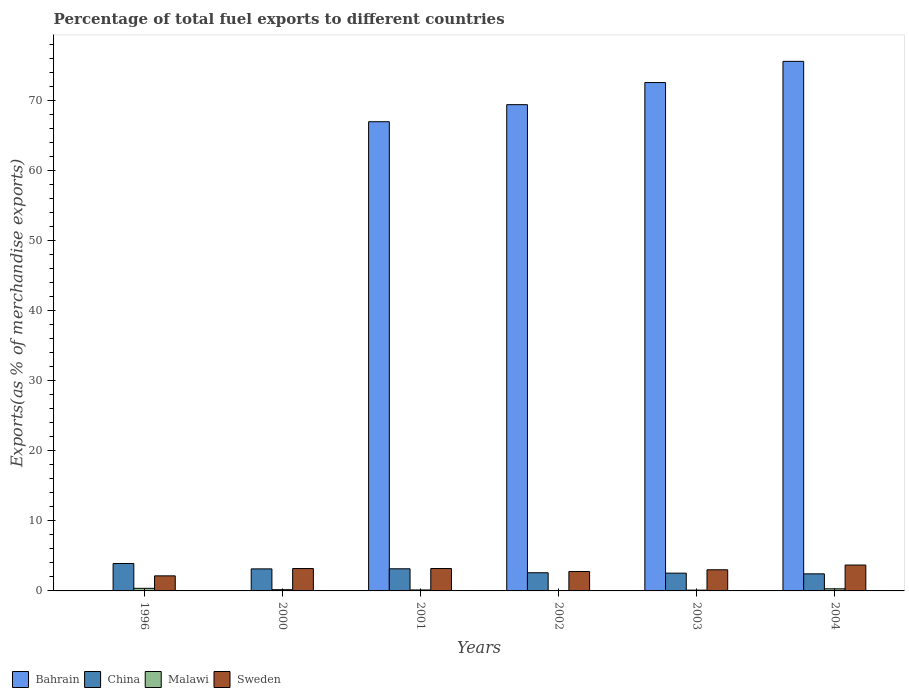How many groups of bars are there?
Provide a short and direct response. 6. How many bars are there on the 2nd tick from the left?
Offer a very short reply. 4. What is the percentage of exports to different countries in Sweden in 2000?
Ensure brevity in your answer.  3.19. Across all years, what is the maximum percentage of exports to different countries in Bahrain?
Ensure brevity in your answer.  75.54. Across all years, what is the minimum percentage of exports to different countries in Sweden?
Offer a terse response. 2.15. In which year was the percentage of exports to different countries in Malawi maximum?
Your response must be concise. 1996. What is the total percentage of exports to different countries in Bahrain in the graph?
Your response must be concise. 284.42. What is the difference between the percentage of exports to different countries in China in 1996 and that in 2004?
Give a very brief answer. 1.47. What is the difference between the percentage of exports to different countries in Sweden in 2000 and the percentage of exports to different countries in Bahrain in 1996?
Make the answer very short. 3.18. What is the average percentage of exports to different countries in Bahrain per year?
Provide a short and direct response. 47.4. In the year 2002, what is the difference between the percentage of exports to different countries in China and percentage of exports to different countries in Bahrain?
Give a very brief answer. -66.77. What is the ratio of the percentage of exports to different countries in China in 2001 to that in 2004?
Your response must be concise. 1.3. Is the difference between the percentage of exports to different countries in China in 2001 and 2002 greater than the difference between the percentage of exports to different countries in Bahrain in 2001 and 2002?
Give a very brief answer. Yes. What is the difference between the highest and the second highest percentage of exports to different countries in China?
Make the answer very short. 0.75. What is the difference between the highest and the lowest percentage of exports to different countries in Bahrain?
Offer a terse response. 75.53. What does the 2nd bar from the left in 2004 represents?
Make the answer very short. China. What does the 1st bar from the right in 2000 represents?
Give a very brief answer. Sweden. Is it the case that in every year, the sum of the percentage of exports to different countries in Malawi and percentage of exports to different countries in Sweden is greater than the percentage of exports to different countries in Bahrain?
Your answer should be very brief. No. How many bars are there?
Provide a short and direct response. 24. How many years are there in the graph?
Make the answer very short. 6. Are the values on the major ticks of Y-axis written in scientific E-notation?
Your answer should be very brief. No. How many legend labels are there?
Provide a succinct answer. 4. How are the legend labels stacked?
Keep it short and to the point. Horizontal. What is the title of the graph?
Keep it short and to the point. Percentage of total fuel exports to different countries. What is the label or title of the X-axis?
Ensure brevity in your answer.  Years. What is the label or title of the Y-axis?
Keep it short and to the point. Exports(as % of merchandise exports). What is the Exports(as % of merchandise exports) in Bahrain in 1996?
Your answer should be compact. 0.02. What is the Exports(as % of merchandise exports) of China in 1996?
Your response must be concise. 3.91. What is the Exports(as % of merchandise exports) of Malawi in 1996?
Make the answer very short. 0.37. What is the Exports(as % of merchandise exports) in Sweden in 1996?
Make the answer very short. 2.15. What is the Exports(as % of merchandise exports) of Bahrain in 2000?
Offer a terse response. 0.04. What is the Exports(as % of merchandise exports) of China in 2000?
Make the answer very short. 3.14. What is the Exports(as % of merchandise exports) in Malawi in 2000?
Keep it short and to the point. 0.18. What is the Exports(as % of merchandise exports) of Sweden in 2000?
Give a very brief answer. 3.19. What is the Exports(as % of merchandise exports) in Bahrain in 2001?
Offer a very short reply. 66.93. What is the Exports(as % of merchandise exports) of China in 2001?
Your response must be concise. 3.16. What is the Exports(as % of merchandise exports) in Malawi in 2001?
Ensure brevity in your answer.  0.14. What is the Exports(as % of merchandise exports) of Sweden in 2001?
Provide a succinct answer. 3.19. What is the Exports(as % of merchandise exports) in Bahrain in 2002?
Your answer should be very brief. 69.37. What is the Exports(as % of merchandise exports) in China in 2002?
Keep it short and to the point. 2.59. What is the Exports(as % of merchandise exports) in Malawi in 2002?
Offer a very short reply. 0.02. What is the Exports(as % of merchandise exports) of Sweden in 2002?
Make the answer very short. 2.77. What is the Exports(as % of merchandise exports) in Bahrain in 2003?
Provide a succinct answer. 72.52. What is the Exports(as % of merchandise exports) in China in 2003?
Your response must be concise. 2.54. What is the Exports(as % of merchandise exports) of Malawi in 2003?
Your response must be concise. 0.11. What is the Exports(as % of merchandise exports) in Sweden in 2003?
Make the answer very short. 3.02. What is the Exports(as % of merchandise exports) in Bahrain in 2004?
Offer a very short reply. 75.54. What is the Exports(as % of merchandise exports) in China in 2004?
Give a very brief answer. 2.43. What is the Exports(as % of merchandise exports) in Malawi in 2004?
Give a very brief answer. 0.3. What is the Exports(as % of merchandise exports) of Sweden in 2004?
Offer a very short reply. 3.69. Across all years, what is the maximum Exports(as % of merchandise exports) in Bahrain?
Your response must be concise. 75.54. Across all years, what is the maximum Exports(as % of merchandise exports) in China?
Your response must be concise. 3.91. Across all years, what is the maximum Exports(as % of merchandise exports) in Malawi?
Make the answer very short. 0.37. Across all years, what is the maximum Exports(as % of merchandise exports) in Sweden?
Ensure brevity in your answer.  3.69. Across all years, what is the minimum Exports(as % of merchandise exports) in Bahrain?
Your response must be concise. 0.02. Across all years, what is the minimum Exports(as % of merchandise exports) in China?
Ensure brevity in your answer.  2.43. Across all years, what is the minimum Exports(as % of merchandise exports) of Malawi?
Your answer should be very brief. 0.02. Across all years, what is the minimum Exports(as % of merchandise exports) of Sweden?
Provide a succinct answer. 2.15. What is the total Exports(as % of merchandise exports) of Bahrain in the graph?
Your answer should be very brief. 284.42. What is the total Exports(as % of merchandise exports) in China in the graph?
Provide a succinct answer. 17.77. What is the total Exports(as % of merchandise exports) of Malawi in the graph?
Ensure brevity in your answer.  1.11. What is the total Exports(as % of merchandise exports) in Sweden in the graph?
Your response must be concise. 18.02. What is the difference between the Exports(as % of merchandise exports) in Bahrain in 1996 and that in 2000?
Make the answer very short. -0.02. What is the difference between the Exports(as % of merchandise exports) of China in 1996 and that in 2000?
Provide a short and direct response. 0.76. What is the difference between the Exports(as % of merchandise exports) of Malawi in 1996 and that in 2000?
Your answer should be very brief. 0.2. What is the difference between the Exports(as % of merchandise exports) in Sweden in 1996 and that in 2000?
Keep it short and to the point. -1.04. What is the difference between the Exports(as % of merchandise exports) of Bahrain in 1996 and that in 2001?
Your response must be concise. -66.92. What is the difference between the Exports(as % of merchandise exports) of China in 1996 and that in 2001?
Ensure brevity in your answer.  0.75. What is the difference between the Exports(as % of merchandise exports) of Malawi in 1996 and that in 2001?
Make the answer very short. 0.24. What is the difference between the Exports(as % of merchandise exports) in Sweden in 1996 and that in 2001?
Your response must be concise. -1.05. What is the difference between the Exports(as % of merchandise exports) in Bahrain in 1996 and that in 2002?
Ensure brevity in your answer.  -69.35. What is the difference between the Exports(as % of merchandise exports) of China in 1996 and that in 2002?
Keep it short and to the point. 1.32. What is the difference between the Exports(as % of merchandise exports) in Malawi in 1996 and that in 2002?
Ensure brevity in your answer.  0.35. What is the difference between the Exports(as % of merchandise exports) of Sweden in 1996 and that in 2002?
Your response must be concise. -0.62. What is the difference between the Exports(as % of merchandise exports) of Bahrain in 1996 and that in 2003?
Your answer should be very brief. -72.5. What is the difference between the Exports(as % of merchandise exports) of China in 1996 and that in 2003?
Offer a terse response. 1.37. What is the difference between the Exports(as % of merchandise exports) of Malawi in 1996 and that in 2003?
Your answer should be very brief. 0.26. What is the difference between the Exports(as % of merchandise exports) of Sweden in 1996 and that in 2003?
Your answer should be very brief. -0.87. What is the difference between the Exports(as % of merchandise exports) of Bahrain in 1996 and that in 2004?
Your answer should be compact. -75.53. What is the difference between the Exports(as % of merchandise exports) in China in 1996 and that in 2004?
Provide a succinct answer. 1.47. What is the difference between the Exports(as % of merchandise exports) of Malawi in 1996 and that in 2004?
Your answer should be very brief. 0.07. What is the difference between the Exports(as % of merchandise exports) of Sweden in 1996 and that in 2004?
Offer a very short reply. -1.54. What is the difference between the Exports(as % of merchandise exports) of Bahrain in 2000 and that in 2001?
Your answer should be compact. -66.89. What is the difference between the Exports(as % of merchandise exports) in China in 2000 and that in 2001?
Give a very brief answer. -0.01. What is the difference between the Exports(as % of merchandise exports) in Malawi in 2000 and that in 2001?
Offer a very short reply. 0.04. What is the difference between the Exports(as % of merchandise exports) in Sweden in 2000 and that in 2001?
Your response must be concise. -0. What is the difference between the Exports(as % of merchandise exports) in Bahrain in 2000 and that in 2002?
Keep it short and to the point. -69.33. What is the difference between the Exports(as % of merchandise exports) of China in 2000 and that in 2002?
Your answer should be compact. 0.55. What is the difference between the Exports(as % of merchandise exports) of Malawi in 2000 and that in 2002?
Your answer should be very brief. 0.16. What is the difference between the Exports(as % of merchandise exports) in Sweden in 2000 and that in 2002?
Make the answer very short. 0.42. What is the difference between the Exports(as % of merchandise exports) of Bahrain in 2000 and that in 2003?
Offer a very short reply. -72.48. What is the difference between the Exports(as % of merchandise exports) of China in 2000 and that in 2003?
Offer a terse response. 0.61. What is the difference between the Exports(as % of merchandise exports) in Malawi in 2000 and that in 2003?
Your answer should be compact. 0.06. What is the difference between the Exports(as % of merchandise exports) of Sweden in 2000 and that in 2003?
Provide a short and direct response. 0.18. What is the difference between the Exports(as % of merchandise exports) in Bahrain in 2000 and that in 2004?
Your answer should be very brief. -75.5. What is the difference between the Exports(as % of merchandise exports) in China in 2000 and that in 2004?
Ensure brevity in your answer.  0.71. What is the difference between the Exports(as % of merchandise exports) in Malawi in 2000 and that in 2004?
Provide a short and direct response. -0.12. What is the difference between the Exports(as % of merchandise exports) in Sweden in 2000 and that in 2004?
Give a very brief answer. -0.5. What is the difference between the Exports(as % of merchandise exports) in Bahrain in 2001 and that in 2002?
Your answer should be very brief. -2.43. What is the difference between the Exports(as % of merchandise exports) of China in 2001 and that in 2002?
Keep it short and to the point. 0.57. What is the difference between the Exports(as % of merchandise exports) in Malawi in 2001 and that in 2002?
Your answer should be very brief. 0.12. What is the difference between the Exports(as % of merchandise exports) in Sweden in 2001 and that in 2002?
Make the answer very short. 0.42. What is the difference between the Exports(as % of merchandise exports) of Bahrain in 2001 and that in 2003?
Offer a terse response. -5.58. What is the difference between the Exports(as % of merchandise exports) in China in 2001 and that in 2003?
Provide a succinct answer. 0.62. What is the difference between the Exports(as % of merchandise exports) in Malawi in 2001 and that in 2003?
Ensure brevity in your answer.  0.02. What is the difference between the Exports(as % of merchandise exports) of Sweden in 2001 and that in 2003?
Offer a terse response. 0.18. What is the difference between the Exports(as % of merchandise exports) in Bahrain in 2001 and that in 2004?
Keep it short and to the point. -8.61. What is the difference between the Exports(as % of merchandise exports) of China in 2001 and that in 2004?
Your response must be concise. 0.72. What is the difference between the Exports(as % of merchandise exports) in Malawi in 2001 and that in 2004?
Your response must be concise. -0.16. What is the difference between the Exports(as % of merchandise exports) in Sweden in 2001 and that in 2004?
Offer a very short reply. -0.5. What is the difference between the Exports(as % of merchandise exports) in Bahrain in 2002 and that in 2003?
Offer a terse response. -3.15. What is the difference between the Exports(as % of merchandise exports) in China in 2002 and that in 2003?
Provide a succinct answer. 0.06. What is the difference between the Exports(as % of merchandise exports) of Malawi in 2002 and that in 2003?
Ensure brevity in your answer.  -0.09. What is the difference between the Exports(as % of merchandise exports) in Sweden in 2002 and that in 2003?
Offer a very short reply. -0.25. What is the difference between the Exports(as % of merchandise exports) in Bahrain in 2002 and that in 2004?
Make the answer very short. -6.18. What is the difference between the Exports(as % of merchandise exports) of China in 2002 and that in 2004?
Ensure brevity in your answer.  0.16. What is the difference between the Exports(as % of merchandise exports) of Malawi in 2002 and that in 2004?
Provide a succinct answer. -0.28. What is the difference between the Exports(as % of merchandise exports) in Sweden in 2002 and that in 2004?
Offer a terse response. -0.92. What is the difference between the Exports(as % of merchandise exports) of Bahrain in 2003 and that in 2004?
Provide a short and direct response. -3.03. What is the difference between the Exports(as % of merchandise exports) in China in 2003 and that in 2004?
Make the answer very short. 0.1. What is the difference between the Exports(as % of merchandise exports) in Malawi in 2003 and that in 2004?
Provide a short and direct response. -0.19. What is the difference between the Exports(as % of merchandise exports) of Sweden in 2003 and that in 2004?
Your answer should be very brief. -0.68. What is the difference between the Exports(as % of merchandise exports) in Bahrain in 1996 and the Exports(as % of merchandise exports) in China in 2000?
Ensure brevity in your answer.  -3.13. What is the difference between the Exports(as % of merchandise exports) of Bahrain in 1996 and the Exports(as % of merchandise exports) of Malawi in 2000?
Make the answer very short. -0.16. What is the difference between the Exports(as % of merchandise exports) in Bahrain in 1996 and the Exports(as % of merchandise exports) in Sweden in 2000?
Make the answer very short. -3.18. What is the difference between the Exports(as % of merchandise exports) of China in 1996 and the Exports(as % of merchandise exports) of Malawi in 2000?
Your response must be concise. 3.73. What is the difference between the Exports(as % of merchandise exports) in China in 1996 and the Exports(as % of merchandise exports) in Sweden in 2000?
Give a very brief answer. 0.71. What is the difference between the Exports(as % of merchandise exports) of Malawi in 1996 and the Exports(as % of merchandise exports) of Sweden in 2000?
Make the answer very short. -2.82. What is the difference between the Exports(as % of merchandise exports) in Bahrain in 1996 and the Exports(as % of merchandise exports) in China in 2001?
Provide a short and direct response. -3.14. What is the difference between the Exports(as % of merchandise exports) in Bahrain in 1996 and the Exports(as % of merchandise exports) in Malawi in 2001?
Your response must be concise. -0.12. What is the difference between the Exports(as % of merchandise exports) of Bahrain in 1996 and the Exports(as % of merchandise exports) of Sweden in 2001?
Provide a short and direct response. -3.18. What is the difference between the Exports(as % of merchandise exports) in China in 1996 and the Exports(as % of merchandise exports) in Malawi in 2001?
Offer a terse response. 3.77. What is the difference between the Exports(as % of merchandise exports) in China in 1996 and the Exports(as % of merchandise exports) in Sweden in 2001?
Your answer should be very brief. 0.71. What is the difference between the Exports(as % of merchandise exports) in Malawi in 1996 and the Exports(as % of merchandise exports) in Sweden in 2001?
Provide a succinct answer. -2.82. What is the difference between the Exports(as % of merchandise exports) of Bahrain in 1996 and the Exports(as % of merchandise exports) of China in 2002?
Make the answer very short. -2.57. What is the difference between the Exports(as % of merchandise exports) in Bahrain in 1996 and the Exports(as % of merchandise exports) in Malawi in 2002?
Your answer should be compact. -0. What is the difference between the Exports(as % of merchandise exports) of Bahrain in 1996 and the Exports(as % of merchandise exports) of Sweden in 2002?
Give a very brief answer. -2.75. What is the difference between the Exports(as % of merchandise exports) of China in 1996 and the Exports(as % of merchandise exports) of Malawi in 2002?
Your answer should be very brief. 3.89. What is the difference between the Exports(as % of merchandise exports) in China in 1996 and the Exports(as % of merchandise exports) in Sweden in 2002?
Your response must be concise. 1.14. What is the difference between the Exports(as % of merchandise exports) in Malawi in 1996 and the Exports(as % of merchandise exports) in Sweden in 2002?
Offer a terse response. -2.4. What is the difference between the Exports(as % of merchandise exports) of Bahrain in 1996 and the Exports(as % of merchandise exports) of China in 2003?
Your answer should be compact. -2.52. What is the difference between the Exports(as % of merchandise exports) of Bahrain in 1996 and the Exports(as % of merchandise exports) of Malawi in 2003?
Keep it short and to the point. -0.09. What is the difference between the Exports(as % of merchandise exports) of Bahrain in 1996 and the Exports(as % of merchandise exports) of Sweden in 2003?
Your response must be concise. -3. What is the difference between the Exports(as % of merchandise exports) of China in 1996 and the Exports(as % of merchandise exports) of Malawi in 2003?
Keep it short and to the point. 3.8. What is the difference between the Exports(as % of merchandise exports) of China in 1996 and the Exports(as % of merchandise exports) of Sweden in 2003?
Make the answer very short. 0.89. What is the difference between the Exports(as % of merchandise exports) in Malawi in 1996 and the Exports(as % of merchandise exports) in Sweden in 2003?
Offer a terse response. -2.64. What is the difference between the Exports(as % of merchandise exports) in Bahrain in 1996 and the Exports(as % of merchandise exports) in China in 2004?
Give a very brief answer. -2.42. What is the difference between the Exports(as % of merchandise exports) in Bahrain in 1996 and the Exports(as % of merchandise exports) in Malawi in 2004?
Keep it short and to the point. -0.28. What is the difference between the Exports(as % of merchandise exports) of Bahrain in 1996 and the Exports(as % of merchandise exports) of Sweden in 2004?
Ensure brevity in your answer.  -3.67. What is the difference between the Exports(as % of merchandise exports) of China in 1996 and the Exports(as % of merchandise exports) of Malawi in 2004?
Your answer should be compact. 3.61. What is the difference between the Exports(as % of merchandise exports) of China in 1996 and the Exports(as % of merchandise exports) of Sweden in 2004?
Your response must be concise. 0.22. What is the difference between the Exports(as % of merchandise exports) of Malawi in 1996 and the Exports(as % of merchandise exports) of Sweden in 2004?
Give a very brief answer. -3.32. What is the difference between the Exports(as % of merchandise exports) of Bahrain in 2000 and the Exports(as % of merchandise exports) of China in 2001?
Your answer should be compact. -3.12. What is the difference between the Exports(as % of merchandise exports) of Bahrain in 2000 and the Exports(as % of merchandise exports) of Malawi in 2001?
Provide a short and direct response. -0.1. What is the difference between the Exports(as % of merchandise exports) in Bahrain in 2000 and the Exports(as % of merchandise exports) in Sweden in 2001?
Your answer should be very brief. -3.15. What is the difference between the Exports(as % of merchandise exports) in China in 2000 and the Exports(as % of merchandise exports) in Malawi in 2001?
Offer a very short reply. 3.01. What is the difference between the Exports(as % of merchandise exports) in China in 2000 and the Exports(as % of merchandise exports) in Sweden in 2001?
Offer a terse response. -0.05. What is the difference between the Exports(as % of merchandise exports) in Malawi in 2000 and the Exports(as % of merchandise exports) in Sweden in 2001?
Keep it short and to the point. -3.02. What is the difference between the Exports(as % of merchandise exports) in Bahrain in 2000 and the Exports(as % of merchandise exports) in China in 2002?
Your answer should be compact. -2.55. What is the difference between the Exports(as % of merchandise exports) of Bahrain in 2000 and the Exports(as % of merchandise exports) of Malawi in 2002?
Your answer should be compact. 0.02. What is the difference between the Exports(as % of merchandise exports) in Bahrain in 2000 and the Exports(as % of merchandise exports) in Sweden in 2002?
Your response must be concise. -2.73. What is the difference between the Exports(as % of merchandise exports) in China in 2000 and the Exports(as % of merchandise exports) in Malawi in 2002?
Your response must be concise. 3.13. What is the difference between the Exports(as % of merchandise exports) of China in 2000 and the Exports(as % of merchandise exports) of Sweden in 2002?
Offer a terse response. 0.37. What is the difference between the Exports(as % of merchandise exports) of Malawi in 2000 and the Exports(as % of merchandise exports) of Sweden in 2002?
Provide a succinct answer. -2.6. What is the difference between the Exports(as % of merchandise exports) of Bahrain in 2000 and the Exports(as % of merchandise exports) of China in 2003?
Offer a very short reply. -2.5. What is the difference between the Exports(as % of merchandise exports) of Bahrain in 2000 and the Exports(as % of merchandise exports) of Malawi in 2003?
Give a very brief answer. -0.07. What is the difference between the Exports(as % of merchandise exports) of Bahrain in 2000 and the Exports(as % of merchandise exports) of Sweden in 2003?
Your answer should be compact. -2.98. What is the difference between the Exports(as % of merchandise exports) of China in 2000 and the Exports(as % of merchandise exports) of Malawi in 2003?
Make the answer very short. 3.03. What is the difference between the Exports(as % of merchandise exports) of China in 2000 and the Exports(as % of merchandise exports) of Sweden in 2003?
Your answer should be very brief. 0.13. What is the difference between the Exports(as % of merchandise exports) in Malawi in 2000 and the Exports(as % of merchandise exports) in Sweden in 2003?
Keep it short and to the point. -2.84. What is the difference between the Exports(as % of merchandise exports) of Bahrain in 2000 and the Exports(as % of merchandise exports) of China in 2004?
Provide a succinct answer. -2.39. What is the difference between the Exports(as % of merchandise exports) in Bahrain in 2000 and the Exports(as % of merchandise exports) in Malawi in 2004?
Your response must be concise. -0.26. What is the difference between the Exports(as % of merchandise exports) of Bahrain in 2000 and the Exports(as % of merchandise exports) of Sweden in 2004?
Offer a terse response. -3.65. What is the difference between the Exports(as % of merchandise exports) in China in 2000 and the Exports(as % of merchandise exports) in Malawi in 2004?
Your answer should be compact. 2.84. What is the difference between the Exports(as % of merchandise exports) of China in 2000 and the Exports(as % of merchandise exports) of Sweden in 2004?
Provide a succinct answer. -0.55. What is the difference between the Exports(as % of merchandise exports) in Malawi in 2000 and the Exports(as % of merchandise exports) in Sweden in 2004?
Your answer should be compact. -3.52. What is the difference between the Exports(as % of merchandise exports) in Bahrain in 2001 and the Exports(as % of merchandise exports) in China in 2002?
Provide a short and direct response. 64.34. What is the difference between the Exports(as % of merchandise exports) of Bahrain in 2001 and the Exports(as % of merchandise exports) of Malawi in 2002?
Your answer should be very brief. 66.92. What is the difference between the Exports(as % of merchandise exports) of Bahrain in 2001 and the Exports(as % of merchandise exports) of Sweden in 2002?
Give a very brief answer. 64.16. What is the difference between the Exports(as % of merchandise exports) in China in 2001 and the Exports(as % of merchandise exports) in Malawi in 2002?
Offer a terse response. 3.14. What is the difference between the Exports(as % of merchandise exports) of China in 2001 and the Exports(as % of merchandise exports) of Sweden in 2002?
Your response must be concise. 0.39. What is the difference between the Exports(as % of merchandise exports) in Malawi in 2001 and the Exports(as % of merchandise exports) in Sweden in 2002?
Your response must be concise. -2.63. What is the difference between the Exports(as % of merchandise exports) in Bahrain in 2001 and the Exports(as % of merchandise exports) in China in 2003?
Offer a terse response. 64.4. What is the difference between the Exports(as % of merchandise exports) of Bahrain in 2001 and the Exports(as % of merchandise exports) of Malawi in 2003?
Provide a short and direct response. 66.82. What is the difference between the Exports(as % of merchandise exports) of Bahrain in 2001 and the Exports(as % of merchandise exports) of Sweden in 2003?
Your response must be concise. 63.92. What is the difference between the Exports(as % of merchandise exports) in China in 2001 and the Exports(as % of merchandise exports) in Malawi in 2003?
Your response must be concise. 3.05. What is the difference between the Exports(as % of merchandise exports) in China in 2001 and the Exports(as % of merchandise exports) in Sweden in 2003?
Make the answer very short. 0.14. What is the difference between the Exports(as % of merchandise exports) in Malawi in 2001 and the Exports(as % of merchandise exports) in Sweden in 2003?
Offer a very short reply. -2.88. What is the difference between the Exports(as % of merchandise exports) of Bahrain in 2001 and the Exports(as % of merchandise exports) of China in 2004?
Keep it short and to the point. 64.5. What is the difference between the Exports(as % of merchandise exports) of Bahrain in 2001 and the Exports(as % of merchandise exports) of Malawi in 2004?
Keep it short and to the point. 66.63. What is the difference between the Exports(as % of merchandise exports) in Bahrain in 2001 and the Exports(as % of merchandise exports) in Sweden in 2004?
Your answer should be very brief. 63.24. What is the difference between the Exports(as % of merchandise exports) in China in 2001 and the Exports(as % of merchandise exports) in Malawi in 2004?
Provide a short and direct response. 2.86. What is the difference between the Exports(as % of merchandise exports) of China in 2001 and the Exports(as % of merchandise exports) of Sweden in 2004?
Provide a succinct answer. -0.54. What is the difference between the Exports(as % of merchandise exports) of Malawi in 2001 and the Exports(as % of merchandise exports) of Sweden in 2004?
Make the answer very short. -3.56. What is the difference between the Exports(as % of merchandise exports) of Bahrain in 2002 and the Exports(as % of merchandise exports) of China in 2003?
Offer a terse response. 66.83. What is the difference between the Exports(as % of merchandise exports) in Bahrain in 2002 and the Exports(as % of merchandise exports) in Malawi in 2003?
Keep it short and to the point. 69.25. What is the difference between the Exports(as % of merchandise exports) of Bahrain in 2002 and the Exports(as % of merchandise exports) of Sweden in 2003?
Keep it short and to the point. 66.35. What is the difference between the Exports(as % of merchandise exports) of China in 2002 and the Exports(as % of merchandise exports) of Malawi in 2003?
Provide a short and direct response. 2.48. What is the difference between the Exports(as % of merchandise exports) in China in 2002 and the Exports(as % of merchandise exports) in Sweden in 2003?
Offer a terse response. -0.42. What is the difference between the Exports(as % of merchandise exports) in Malawi in 2002 and the Exports(as % of merchandise exports) in Sweden in 2003?
Your answer should be very brief. -3. What is the difference between the Exports(as % of merchandise exports) in Bahrain in 2002 and the Exports(as % of merchandise exports) in China in 2004?
Ensure brevity in your answer.  66.93. What is the difference between the Exports(as % of merchandise exports) of Bahrain in 2002 and the Exports(as % of merchandise exports) of Malawi in 2004?
Give a very brief answer. 69.07. What is the difference between the Exports(as % of merchandise exports) of Bahrain in 2002 and the Exports(as % of merchandise exports) of Sweden in 2004?
Make the answer very short. 65.67. What is the difference between the Exports(as % of merchandise exports) in China in 2002 and the Exports(as % of merchandise exports) in Malawi in 2004?
Offer a terse response. 2.29. What is the difference between the Exports(as % of merchandise exports) in China in 2002 and the Exports(as % of merchandise exports) in Sweden in 2004?
Ensure brevity in your answer.  -1.1. What is the difference between the Exports(as % of merchandise exports) of Malawi in 2002 and the Exports(as % of merchandise exports) of Sweden in 2004?
Your answer should be very brief. -3.67. What is the difference between the Exports(as % of merchandise exports) in Bahrain in 2003 and the Exports(as % of merchandise exports) in China in 2004?
Keep it short and to the point. 70.08. What is the difference between the Exports(as % of merchandise exports) of Bahrain in 2003 and the Exports(as % of merchandise exports) of Malawi in 2004?
Make the answer very short. 72.22. What is the difference between the Exports(as % of merchandise exports) in Bahrain in 2003 and the Exports(as % of merchandise exports) in Sweden in 2004?
Your response must be concise. 68.83. What is the difference between the Exports(as % of merchandise exports) of China in 2003 and the Exports(as % of merchandise exports) of Malawi in 2004?
Keep it short and to the point. 2.24. What is the difference between the Exports(as % of merchandise exports) of China in 2003 and the Exports(as % of merchandise exports) of Sweden in 2004?
Give a very brief answer. -1.16. What is the difference between the Exports(as % of merchandise exports) in Malawi in 2003 and the Exports(as % of merchandise exports) in Sweden in 2004?
Offer a very short reply. -3.58. What is the average Exports(as % of merchandise exports) in Bahrain per year?
Your response must be concise. 47.4. What is the average Exports(as % of merchandise exports) of China per year?
Give a very brief answer. 2.96. What is the average Exports(as % of merchandise exports) of Malawi per year?
Provide a short and direct response. 0.19. What is the average Exports(as % of merchandise exports) of Sweden per year?
Your answer should be compact. 3. In the year 1996, what is the difference between the Exports(as % of merchandise exports) in Bahrain and Exports(as % of merchandise exports) in China?
Make the answer very short. -3.89. In the year 1996, what is the difference between the Exports(as % of merchandise exports) of Bahrain and Exports(as % of merchandise exports) of Malawi?
Give a very brief answer. -0.35. In the year 1996, what is the difference between the Exports(as % of merchandise exports) of Bahrain and Exports(as % of merchandise exports) of Sweden?
Offer a terse response. -2.13. In the year 1996, what is the difference between the Exports(as % of merchandise exports) in China and Exports(as % of merchandise exports) in Malawi?
Make the answer very short. 3.54. In the year 1996, what is the difference between the Exports(as % of merchandise exports) of China and Exports(as % of merchandise exports) of Sweden?
Provide a succinct answer. 1.76. In the year 1996, what is the difference between the Exports(as % of merchandise exports) in Malawi and Exports(as % of merchandise exports) in Sweden?
Keep it short and to the point. -1.78. In the year 2000, what is the difference between the Exports(as % of merchandise exports) of Bahrain and Exports(as % of merchandise exports) of China?
Provide a short and direct response. -3.1. In the year 2000, what is the difference between the Exports(as % of merchandise exports) in Bahrain and Exports(as % of merchandise exports) in Malawi?
Provide a succinct answer. -0.14. In the year 2000, what is the difference between the Exports(as % of merchandise exports) in Bahrain and Exports(as % of merchandise exports) in Sweden?
Make the answer very short. -3.15. In the year 2000, what is the difference between the Exports(as % of merchandise exports) of China and Exports(as % of merchandise exports) of Malawi?
Make the answer very short. 2.97. In the year 2000, what is the difference between the Exports(as % of merchandise exports) in China and Exports(as % of merchandise exports) in Sweden?
Your answer should be very brief. -0.05. In the year 2000, what is the difference between the Exports(as % of merchandise exports) in Malawi and Exports(as % of merchandise exports) in Sweden?
Offer a very short reply. -3.02. In the year 2001, what is the difference between the Exports(as % of merchandise exports) of Bahrain and Exports(as % of merchandise exports) of China?
Provide a succinct answer. 63.78. In the year 2001, what is the difference between the Exports(as % of merchandise exports) in Bahrain and Exports(as % of merchandise exports) in Malawi?
Your answer should be compact. 66.8. In the year 2001, what is the difference between the Exports(as % of merchandise exports) in Bahrain and Exports(as % of merchandise exports) in Sweden?
Your answer should be compact. 63.74. In the year 2001, what is the difference between the Exports(as % of merchandise exports) of China and Exports(as % of merchandise exports) of Malawi?
Your answer should be very brief. 3.02. In the year 2001, what is the difference between the Exports(as % of merchandise exports) in China and Exports(as % of merchandise exports) in Sweden?
Your response must be concise. -0.04. In the year 2001, what is the difference between the Exports(as % of merchandise exports) of Malawi and Exports(as % of merchandise exports) of Sweden?
Provide a succinct answer. -3.06. In the year 2002, what is the difference between the Exports(as % of merchandise exports) of Bahrain and Exports(as % of merchandise exports) of China?
Your answer should be compact. 66.77. In the year 2002, what is the difference between the Exports(as % of merchandise exports) of Bahrain and Exports(as % of merchandise exports) of Malawi?
Your answer should be very brief. 69.35. In the year 2002, what is the difference between the Exports(as % of merchandise exports) in Bahrain and Exports(as % of merchandise exports) in Sweden?
Your answer should be compact. 66.6. In the year 2002, what is the difference between the Exports(as % of merchandise exports) of China and Exports(as % of merchandise exports) of Malawi?
Provide a short and direct response. 2.57. In the year 2002, what is the difference between the Exports(as % of merchandise exports) in China and Exports(as % of merchandise exports) in Sweden?
Provide a succinct answer. -0.18. In the year 2002, what is the difference between the Exports(as % of merchandise exports) in Malawi and Exports(as % of merchandise exports) in Sweden?
Your response must be concise. -2.75. In the year 2003, what is the difference between the Exports(as % of merchandise exports) of Bahrain and Exports(as % of merchandise exports) of China?
Your response must be concise. 69.98. In the year 2003, what is the difference between the Exports(as % of merchandise exports) of Bahrain and Exports(as % of merchandise exports) of Malawi?
Ensure brevity in your answer.  72.41. In the year 2003, what is the difference between the Exports(as % of merchandise exports) in Bahrain and Exports(as % of merchandise exports) in Sweden?
Ensure brevity in your answer.  69.5. In the year 2003, what is the difference between the Exports(as % of merchandise exports) of China and Exports(as % of merchandise exports) of Malawi?
Offer a very short reply. 2.42. In the year 2003, what is the difference between the Exports(as % of merchandise exports) of China and Exports(as % of merchandise exports) of Sweden?
Provide a short and direct response. -0.48. In the year 2003, what is the difference between the Exports(as % of merchandise exports) in Malawi and Exports(as % of merchandise exports) in Sweden?
Provide a short and direct response. -2.9. In the year 2004, what is the difference between the Exports(as % of merchandise exports) of Bahrain and Exports(as % of merchandise exports) of China?
Give a very brief answer. 73.11. In the year 2004, what is the difference between the Exports(as % of merchandise exports) of Bahrain and Exports(as % of merchandise exports) of Malawi?
Provide a short and direct response. 75.25. In the year 2004, what is the difference between the Exports(as % of merchandise exports) of Bahrain and Exports(as % of merchandise exports) of Sweden?
Make the answer very short. 71.85. In the year 2004, what is the difference between the Exports(as % of merchandise exports) in China and Exports(as % of merchandise exports) in Malawi?
Provide a short and direct response. 2.13. In the year 2004, what is the difference between the Exports(as % of merchandise exports) in China and Exports(as % of merchandise exports) in Sweden?
Give a very brief answer. -1.26. In the year 2004, what is the difference between the Exports(as % of merchandise exports) in Malawi and Exports(as % of merchandise exports) in Sweden?
Give a very brief answer. -3.39. What is the ratio of the Exports(as % of merchandise exports) in Bahrain in 1996 to that in 2000?
Your answer should be very brief. 0.44. What is the ratio of the Exports(as % of merchandise exports) of China in 1996 to that in 2000?
Your response must be concise. 1.24. What is the ratio of the Exports(as % of merchandise exports) in Malawi in 1996 to that in 2000?
Your answer should be very brief. 2.12. What is the ratio of the Exports(as % of merchandise exports) in Sweden in 1996 to that in 2000?
Your answer should be compact. 0.67. What is the ratio of the Exports(as % of merchandise exports) of Bahrain in 1996 to that in 2001?
Give a very brief answer. 0. What is the ratio of the Exports(as % of merchandise exports) in China in 1996 to that in 2001?
Your answer should be very brief. 1.24. What is the ratio of the Exports(as % of merchandise exports) in Malawi in 1996 to that in 2001?
Make the answer very short. 2.73. What is the ratio of the Exports(as % of merchandise exports) in Sweden in 1996 to that in 2001?
Your response must be concise. 0.67. What is the ratio of the Exports(as % of merchandise exports) in China in 1996 to that in 2002?
Provide a succinct answer. 1.51. What is the ratio of the Exports(as % of merchandise exports) of Malawi in 1996 to that in 2002?
Offer a terse response. 20.62. What is the ratio of the Exports(as % of merchandise exports) in Sweden in 1996 to that in 2002?
Offer a very short reply. 0.78. What is the ratio of the Exports(as % of merchandise exports) of China in 1996 to that in 2003?
Offer a terse response. 1.54. What is the ratio of the Exports(as % of merchandise exports) in Malawi in 1996 to that in 2003?
Provide a short and direct response. 3.32. What is the ratio of the Exports(as % of merchandise exports) of Sweden in 1996 to that in 2003?
Your answer should be very brief. 0.71. What is the ratio of the Exports(as % of merchandise exports) in Bahrain in 1996 to that in 2004?
Provide a short and direct response. 0. What is the ratio of the Exports(as % of merchandise exports) in China in 1996 to that in 2004?
Offer a very short reply. 1.61. What is the ratio of the Exports(as % of merchandise exports) of Malawi in 1996 to that in 2004?
Your answer should be very brief. 1.24. What is the ratio of the Exports(as % of merchandise exports) of Sweden in 1996 to that in 2004?
Make the answer very short. 0.58. What is the ratio of the Exports(as % of merchandise exports) in Bahrain in 2000 to that in 2001?
Make the answer very short. 0. What is the ratio of the Exports(as % of merchandise exports) in China in 2000 to that in 2001?
Make the answer very short. 1. What is the ratio of the Exports(as % of merchandise exports) in Malawi in 2000 to that in 2001?
Your answer should be very brief. 1.29. What is the ratio of the Exports(as % of merchandise exports) in Sweden in 2000 to that in 2001?
Provide a succinct answer. 1. What is the ratio of the Exports(as % of merchandise exports) of Bahrain in 2000 to that in 2002?
Keep it short and to the point. 0. What is the ratio of the Exports(as % of merchandise exports) in China in 2000 to that in 2002?
Keep it short and to the point. 1.21. What is the ratio of the Exports(as % of merchandise exports) of Malawi in 2000 to that in 2002?
Your answer should be very brief. 9.72. What is the ratio of the Exports(as % of merchandise exports) in Sweden in 2000 to that in 2002?
Provide a short and direct response. 1.15. What is the ratio of the Exports(as % of merchandise exports) of Bahrain in 2000 to that in 2003?
Your answer should be very brief. 0. What is the ratio of the Exports(as % of merchandise exports) of China in 2000 to that in 2003?
Offer a very short reply. 1.24. What is the ratio of the Exports(as % of merchandise exports) of Malawi in 2000 to that in 2003?
Keep it short and to the point. 1.56. What is the ratio of the Exports(as % of merchandise exports) of Sweden in 2000 to that in 2003?
Your answer should be very brief. 1.06. What is the ratio of the Exports(as % of merchandise exports) of China in 2000 to that in 2004?
Your response must be concise. 1.29. What is the ratio of the Exports(as % of merchandise exports) in Malawi in 2000 to that in 2004?
Provide a succinct answer. 0.59. What is the ratio of the Exports(as % of merchandise exports) of Sweden in 2000 to that in 2004?
Keep it short and to the point. 0.86. What is the ratio of the Exports(as % of merchandise exports) of Bahrain in 2001 to that in 2002?
Ensure brevity in your answer.  0.96. What is the ratio of the Exports(as % of merchandise exports) in China in 2001 to that in 2002?
Your response must be concise. 1.22. What is the ratio of the Exports(as % of merchandise exports) of Malawi in 2001 to that in 2002?
Ensure brevity in your answer.  7.55. What is the ratio of the Exports(as % of merchandise exports) in Sweden in 2001 to that in 2002?
Offer a very short reply. 1.15. What is the ratio of the Exports(as % of merchandise exports) of Bahrain in 2001 to that in 2003?
Offer a very short reply. 0.92. What is the ratio of the Exports(as % of merchandise exports) of China in 2001 to that in 2003?
Your response must be concise. 1.24. What is the ratio of the Exports(as % of merchandise exports) in Malawi in 2001 to that in 2003?
Keep it short and to the point. 1.21. What is the ratio of the Exports(as % of merchandise exports) in Sweden in 2001 to that in 2003?
Keep it short and to the point. 1.06. What is the ratio of the Exports(as % of merchandise exports) in Bahrain in 2001 to that in 2004?
Ensure brevity in your answer.  0.89. What is the ratio of the Exports(as % of merchandise exports) of China in 2001 to that in 2004?
Provide a short and direct response. 1.3. What is the ratio of the Exports(as % of merchandise exports) of Malawi in 2001 to that in 2004?
Your response must be concise. 0.45. What is the ratio of the Exports(as % of merchandise exports) in Sweden in 2001 to that in 2004?
Your response must be concise. 0.86. What is the ratio of the Exports(as % of merchandise exports) of Bahrain in 2002 to that in 2003?
Provide a short and direct response. 0.96. What is the ratio of the Exports(as % of merchandise exports) in Malawi in 2002 to that in 2003?
Offer a terse response. 0.16. What is the ratio of the Exports(as % of merchandise exports) of Sweden in 2002 to that in 2003?
Offer a very short reply. 0.92. What is the ratio of the Exports(as % of merchandise exports) of Bahrain in 2002 to that in 2004?
Your response must be concise. 0.92. What is the ratio of the Exports(as % of merchandise exports) of China in 2002 to that in 2004?
Your answer should be very brief. 1.06. What is the ratio of the Exports(as % of merchandise exports) of Malawi in 2002 to that in 2004?
Provide a short and direct response. 0.06. What is the ratio of the Exports(as % of merchandise exports) in Sweden in 2002 to that in 2004?
Keep it short and to the point. 0.75. What is the ratio of the Exports(as % of merchandise exports) in Bahrain in 2003 to that in 2004?
Keep it short and to the point. 0.96. What is the ratio of the Exports(as % of merchandise exports) of China in 2003 to that in 2004?
Your answer should be compact. 1.04. What is the ratio of the Exports(as % of merchandise exports) in Malawi in 2003 to that in 2004?
Ensure brevity in your answer.  0.37. What is the ratio of the Exports(as % of merchandise exports) in Sweden in 2003 to that in 2004?
Give a very brief answer. 0.82. What is the difference between the highest and the second highest Exports(as % of merchandise exports) of Bahrain?
Provide a short and direct response. 3.03. What is the difference between the highest and the second highest Exports(as % of merchandise exports) in China?
Provide a short and direct response. 0.75. What is the difference between the highest and the second highest Exports(as % of merchandise exports) in Malawi?
Your answer should be compact. 0.07. What is the difference between the highest and the second highest Exports(as % of merchandise exports) of Sweden?
Your answer should be compact. 0.5. What is the difference between the highest and the lowest Exports(as % of merchandise exports) in Bahrain?
Offer a terse response. 75.53. What is the difference between the highest and the lowest Exports(as % of merchandise exports) of China?
Your answer should be very brief. 1.47. What is the difference between the highest and the lowest Exports(as % of merchandise exports) of Malawi?
Provide a succinct answer. 0.35. What is the difference between the highest and the lowest Exports(as % of merchandise exports) in Sweden?
Your response must be concise. 1.54. 